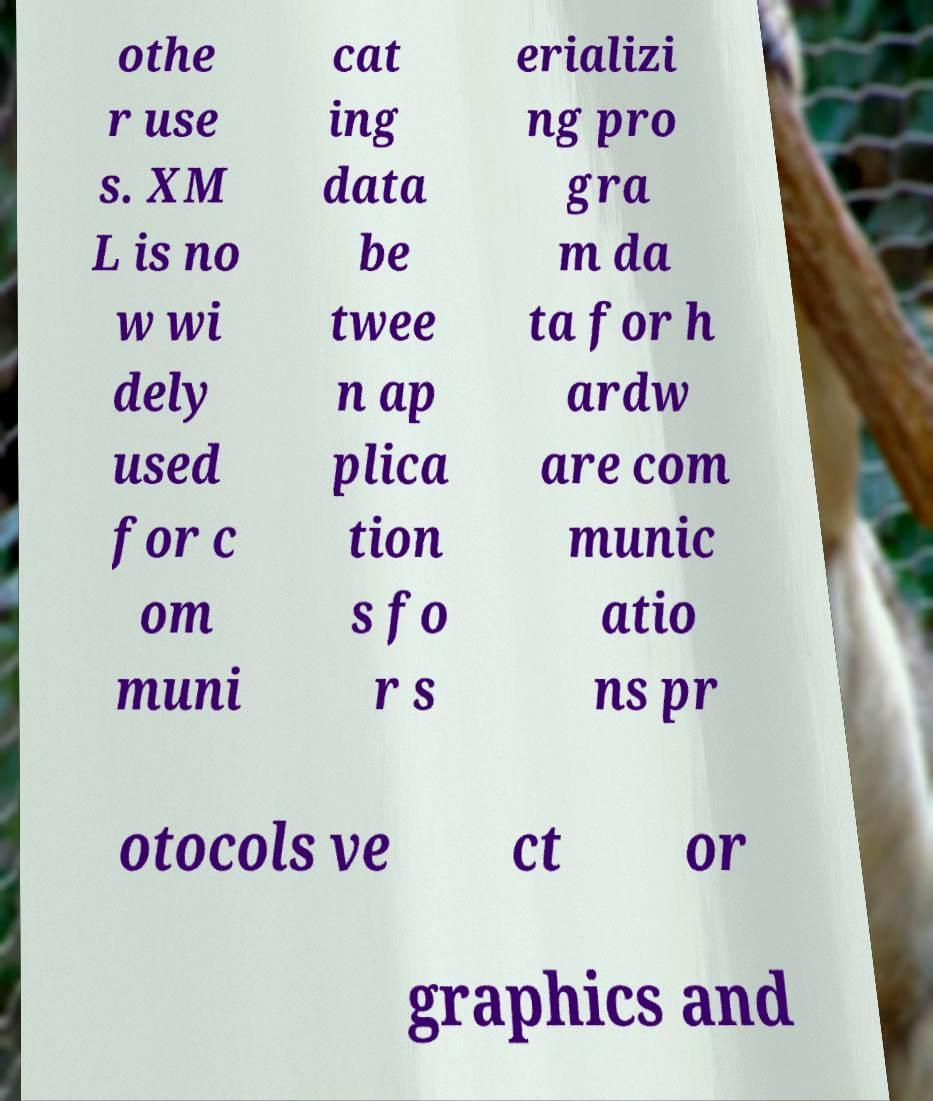Can you read and provide the text displayed in the image?This photo seems to have some interesting text. Can you extract and type it out for me? othe r use s. XM L is no w wi dely used for c om muni cat ing data be twee n ap plica tion s fo r s erializi ng pro gra m da ta for h ardw are com munic atio ns pr otocols ve ct or graphics and 